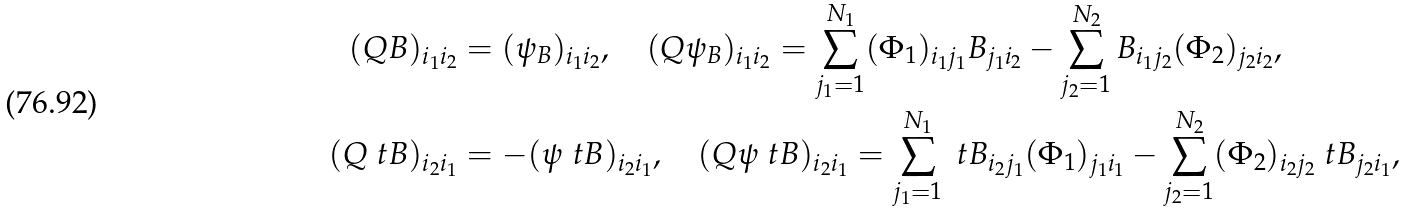Convert formula to latex. <formula><loc_0><loc_0><loc_500><loc_500>( Q B ) _ { i _ { 1 } i _ { 2 } } & = ( \psi _ { B } ) _ { i _ { 1 } i _ { 2 } } , \quad ( Q { \psi _ { B } } ) _ { i _ { 1 } i _ { 2 } } = \sum _ { j _ { 1 } = 1 } ^ { N _ { 1 } } ( \Phi _ { 1 } ) _ { i _ { 1 } j _ { 1 } } B _ { j _ { 1 } i _ { 2 } } - \sum _ { j _ { 2 } = 1 } ^ { N _ { 2 } } B _ { i _ { 1 } j _ { 2 } } ( \Phi _ { 2 } ) _ { j _ { 2 } i _ { 2 } } , \\ ( Q \ t B ) _ { i _ { 2 } i _ { 1 } } & = - ( \psi _ { \ } t B ) _ { i _ { 2 } i _ { 1 } } , \quad ( Q { \psi _ { \ } t B } ) _ { i _ { 2 } i _ { 1 } } = \sum _ { j _ { 1 } = 1 } ^ { N _ { 1 } } \ t B _ { i _ { 2 } j _ { 1 } } ( \Phi _ { 1 } ) _ { j _ { 1 } i _ { 1 } } - \sum _ { j _ { 2 } = 1 } ^ { N _ { 2 } } ( \Phi _ { 2 } ) _ { i _ { 2 } j _ { 2 } } \ t B _ { j _ { 2 } i _ { 1 } } ,</formula> 